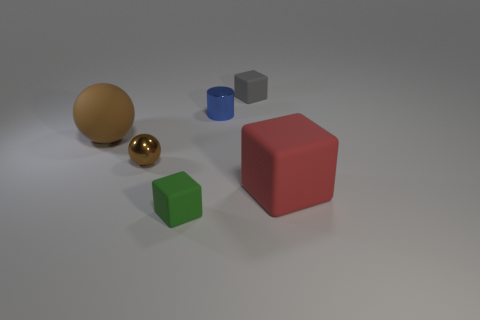Add 1 cyan matte spheres. How many objects exist? 7 Subtract all cylinders. How many objects are left? 5 Add 6 cyan matte cylinders. How many cyan matte cylinders exist? 6 Subtract 0 blue cubes. How many objects are left? 6 Subtract all red cubes. Subtract all tiny metallic cylinders. How many objects are left? 4 Add 4 small matte blocks. How many small matte blocks are left? 6 